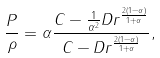Convert formula to latex. <formula><loc_0><loc_0><loc_500><loc_500>\frac { P } { \rho } = \alpha \frac { C - \frac { 1 } { \alpha ^ { 2 } } D r ^ { \frac { 2 ( 1 - \alpha ) } { 1 + \alpha } } } { C - D r ^ { \frac { 2 ( 1 - \alpha ) } { 1 + \alpha } } } ,</formula> 